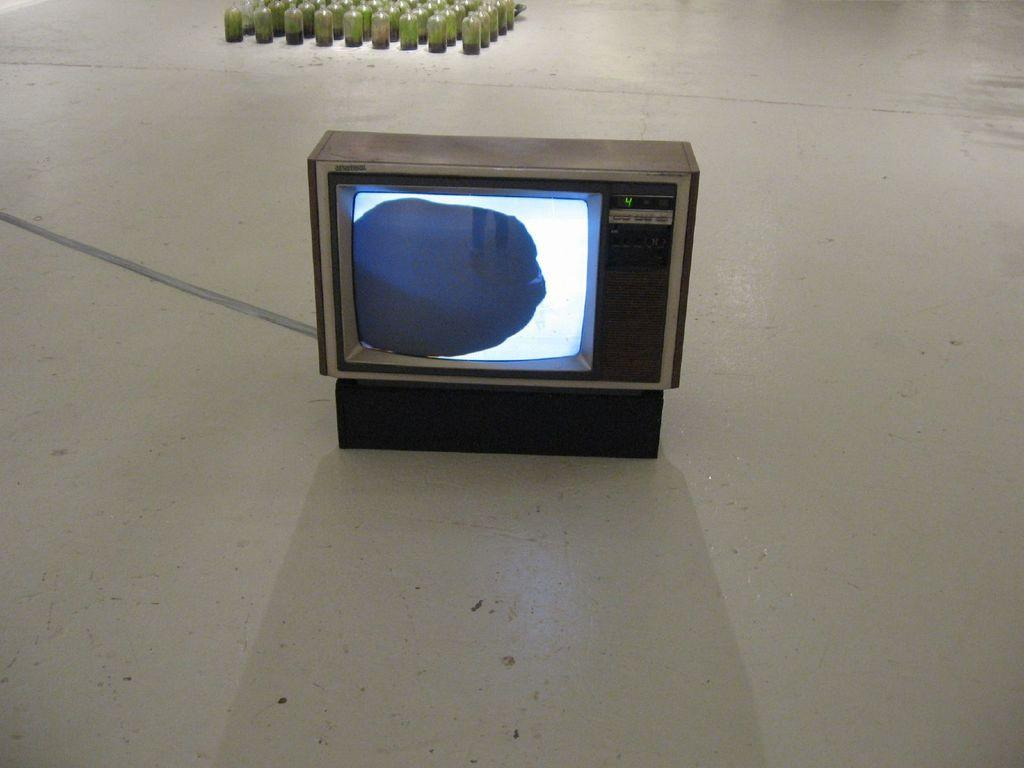<image>
Create a compact narrative representing the image presented. A small old school Tv is set to channel number four. 